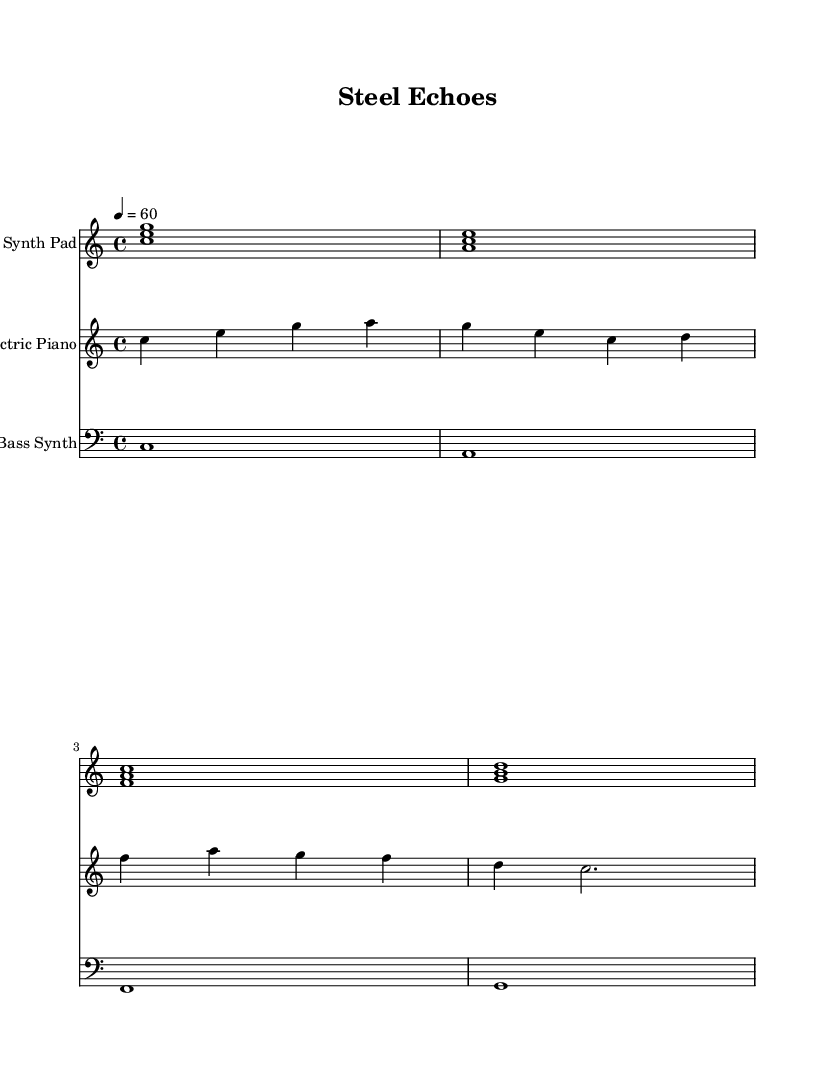What is the key signature of this music? The key signature is indicated at the beginning of the staff. In this case, it shows C major, which has no sharps or flats.
Answer: C major What is the time signature of this music? The time signature appears at the beginning of the score, showing a fraction. In this instance, it is 4/4, which indicates four beats per measure.
Answer: 4/4 What is the tempo marking used in the score? The tempo marking is indicated in beats per minute at the beginning of the score. Here, it shows a quarter note equals 60 beats, which is a moderate pace.
Answer: 60 Which instrument is notated in the bass clef? The bass clef is used for lower-pitched notes, typically for bass instruments. In this score, the instrument shown in the bass clef is the Bass Synth.
Answer: Bass Synth How many measures are in the electric piano part? By counting the number of vertical bars in the electric piano staff, we can see that there are four measures. Each measure is separated by a vertical line.
Answer: 4 Which chord is played in the first measure of the synth pad? The first measure of the synth pad contains three notes sounding together, which form a chord. Here, the notes are C, E, and G, forming a C major chord.
Answer: C major What rhythmic note value is the longest note in the bass synth part? By examining the bass synth part, we note that the longest note value is a whole note, which receives four beats in the 4/4 time signature.
Answer: whole note 